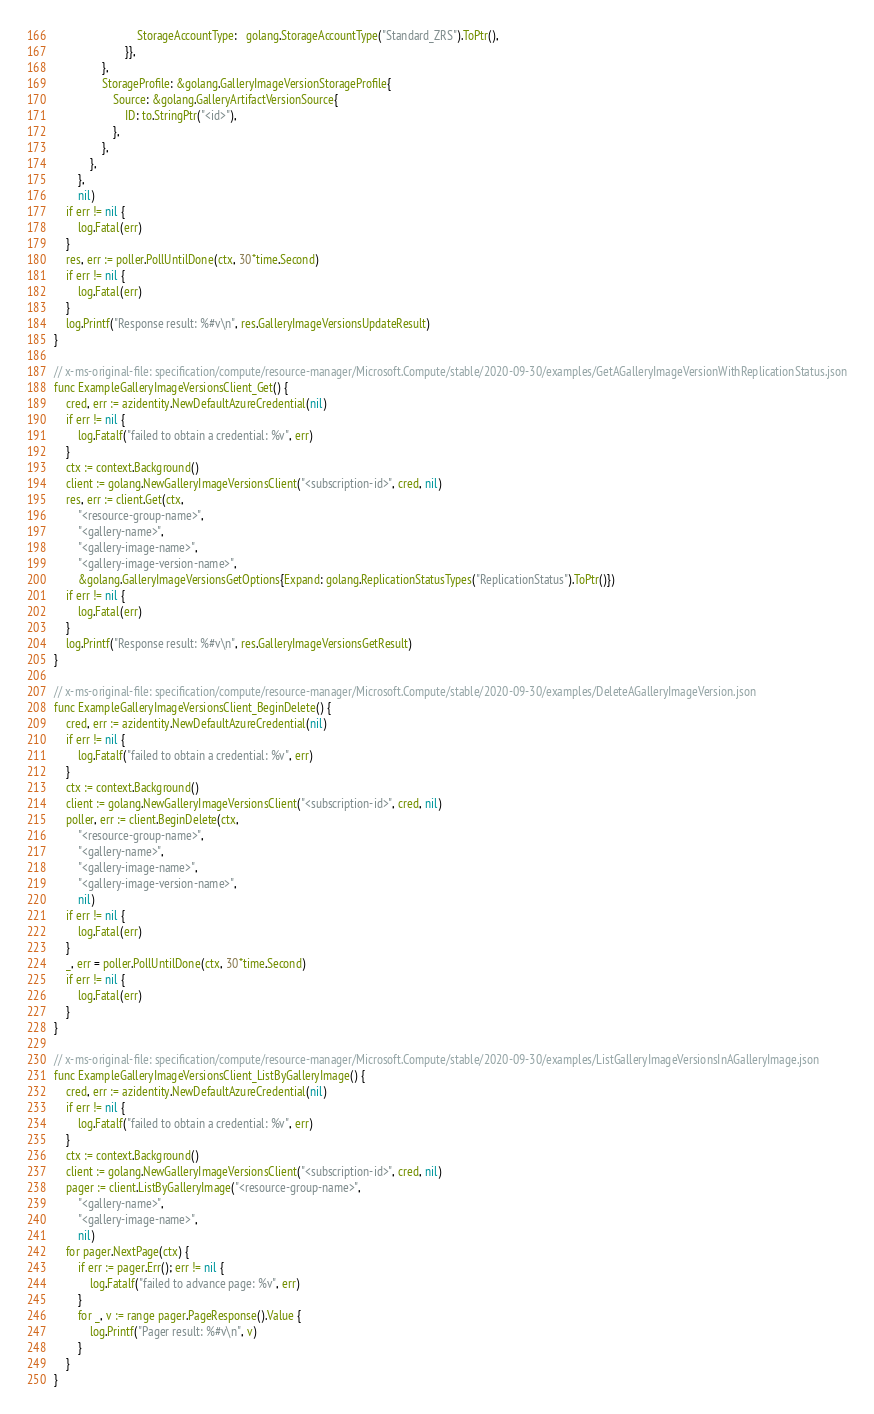Convert code to text. <code><loc_0><loc_0><loc_500><loc_500><_Go_>							StorageAccountType:   golang.StorageAccountType("Standard_ZRS").ToPtr(),
						}},
				},
				StorageProfile: &golang.GalleryImageVersionStorageProfile{
					Source: &golang.GalleryArtifactVersionSource{
						ID: to.StringPtr("<id>"),
					},
				},
			},
		},
		nil)
	if err != nil {
		log.Fatal(err)
	}
	res, err := poller.PollUntilDone(ctx, 30*time.Second)
	if err != nil {
		log.Fatal(err)
	}
	log.Printf("Response result: %#v\n", res.GalleryImageVersionsUpdateResult)
}

// x-ms-original-file: specification/compute/resource-manager/Microsoft.Compute/stable/2020-09-30/examples/GetAGalleryImageVersionWithReplicationStatus.json
func ExampleGalleryImageVersionsClient_Get() {
	cred, err := azidentity.NewDefaultAzureCredential(nil)
	if err != nil {
		log.Fatalf("failed to obtain a credential: %v", err)
	}
	ctx := context.Background()
	client := golang.NewGalleryImageVersionsClient("<subscription-id>", cred, nil)
	res, err := client.Get(ctx,
		"<resource-group-name>",
		"<gallery-name>",
		"<gallery-image-name>",
		"<gallery-image-version-name>",
		&golang.GalleryImageVersionsGetOptions{Expand: golang.ReplicationStatusTypes("ReplicationStatus").ToPtr()})
	if err != nil {
		log.Fatal(err)
	}
	log.Printf("Response result: %#v\n", res.GalleryImageVersionsGetResult)
}

// x-ms-original-file: specification/compute/resource-manager/Microsoft.Compute/stable/2020-09-30/examples/DeleteAGalleryImageVersion.json
func ExampleGalleryImageVersionsClient_BeginDelete() {
	cred, err := azidentity.NewDefaultAzureCredential(nil)
	if err != nil {
		log.Fatalf("failed to obtain a credential: %v", err)
	}
	ctx := context.Background()
	client := golang.NewGalleryImageVersionsClient("<subscription-id>", cred, nil)
	poller, err := client.BeginDelete(ctx,
		"<resource-group-name>",
		"<gallery-name>",
		"<gallery-image-name>",
		"<gallery-image-version-name>",
		nil)
	if err != nil {
		log.Fatal(err)
	}
	_, err = poller.PollUntilDone(ctx, 30*time.Second)
	if err != nil {
		log.Fatal(err)
	}
}

// x-ms-original-file: specification/compute/resource-manager/Microsoft.Compute/stable/2020-09-30/examples/ListGalleryImageVersionsInAGalleryImage.json
func ExampleGalleryImageVersionsClient_ListByGalleryImage() {
	cred, err := azidentity.NewDefaultAzureCredential(nil)
	if err != nil {
		log.Fatalf("failed to obtain a credential: %v", err)
	}
	ctx := context.Background()
	client := golang.NewGalleryImageVersionsClient("<subscription-id>", cred, nil)
	pager := client.ListByGalleryImage("<resource-group-name>",
		"<gallery-name>",
		"<gallery-image-name>",
		nil)
	for pager.NextPage(ctx) {
		if err := pager.Err(); err != nil {
			log.Fatalf("failed to advance page: %v", err)
		}
		for _, v := range pager.PageResponse().Value {
			log.Printf("Pager result: %#v\n", v)
		}
	}
}
</code> 